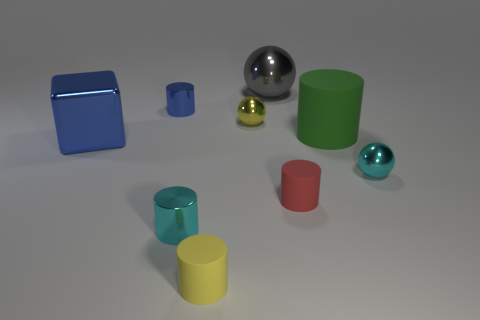Subtract all red cylinders. How many cylinders are left? 4 Subtract all large cylinders. How many cylinders are left? 4 Subtract all yellow cylinders. Subtract all red cubes. How many cylinders are left? 4 Add 1 blue cylinders. How many objects exist? 10 Subtract all balls. How many objects are left? 6 Subtract 0 blue spheres. How many objects are left? 9 Subtract all large gray things. Subtract all blue metal cubes. How many objects are left? 7 Add 9 red cylinders. How many red cylinders are left? 10 Add 6 yellow rubber cylinders. How many yellow rubber cylinders exist? 7 